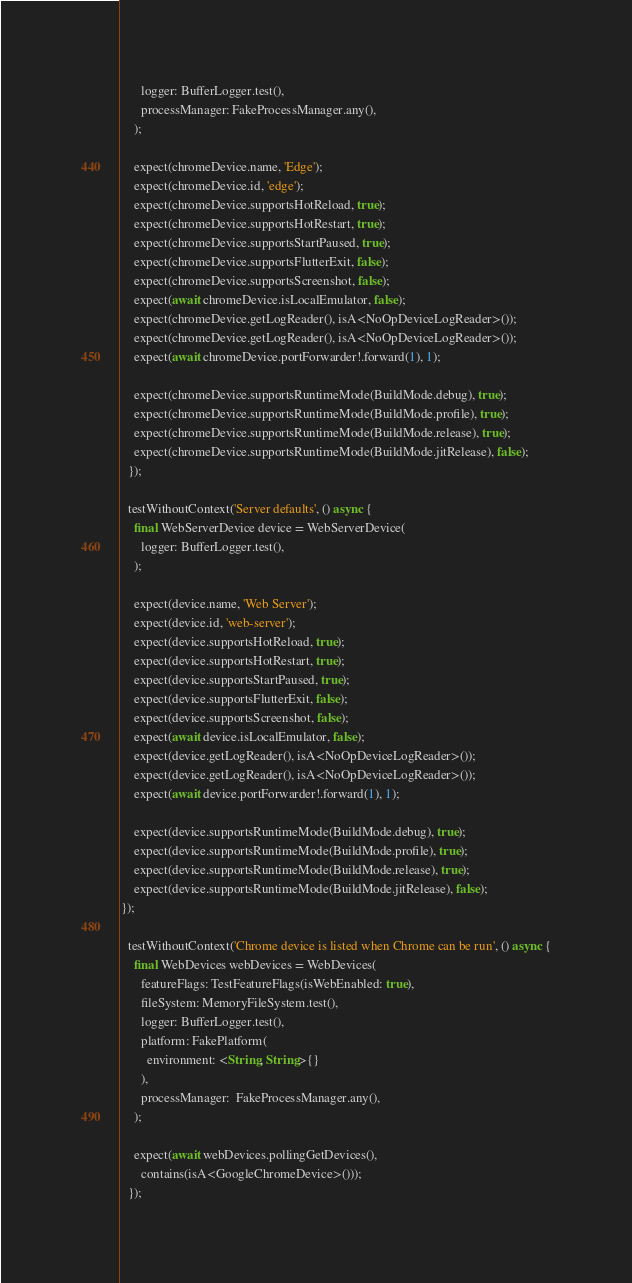Convert code to text. <code><loc_0><loc_0><loc_500><loc_500><_Dart_>      logger: BufferLogger.test(),
      processManager: FakeProcessManager.any(),
    );

    expect(chromeDevice.name, 'Edge');
    expect(chromeDevice.id, 'edge');
    expect(chromeDevice.supportsHotReload, true);
    expect(chromeDevice.supportsHotRestart, true);
    expect(chromeDevice.supportsStartPaused, true);
    expect(chromeDevice.supportsFlutterExit, false);
    expect(chromeDevice.supportsScreenshot, false);
    expect(await chromeDevice.isLocalEmulator, false);
    expect(chromeDevice.getLogReader(), isA<NoOpDeviceLogReader>());
    expect(chromeDevice.getLogReader(), isA<NoOpDeviceLogReader>());
    expect(await chromeDevice.portForwarder!.forward(1), 1);

    expect(chromeDevice.supportsRuntimeMode(BuildMode.debug), true);
    expect(chromeDevice.supportsRuntimeMode(BuildMode.profile), true);
    expect(chromeDevice.supportsRuntimeMode(BuildMode.release), true);
    expect(chromeDevice.supportsRuntimeMode(BuildMode.jitRelease), false);
  });

  testWithoutContext('Server defaults', () async {
    final WebServerDevice device = WebServerDevice(
      logger: BufferLogger.test(),
    );

    expect(device.name, 'Web Server');
    expect(device.id, 'web-server');
    expect(device.supportsHotReload, true);
    expect(device.supportsHotRestart, true);
    expect(device.supportsStartPaused, true);
    expect(device.supportsFlutterExit, false);
    expect(device.supportsScreenshot, false);
    expect(await device.isLocalEmulator, false);
    expect(device.getLogReader(), isA<NoOpDeviceLogReader>());
    expect(device.getLogReader(), isA<NoOpDeviceLogReader>());
    expect(await device.portForwarder!.forward(1), 1);

    expect(device.supportsRuntimeMode(BuildMode.debug), true);
    expect(device.supportsRuntimeMode(BuildMode.profile), true);
    expect(device.supportsRuntimeMode(BuildMode.release), true);
    expect(device.supportsRuntimeMode(BuildMode.jitRelease), false);
});

  testWithoutContext('Chrome device is listed when Chrome can be run', () async {
    final WebDevices webDevices = WebDevices(
      featureFlags: TestFeatureFlags(isWebEnabled: true),
      fileSystem: MemoryFileSystem.test(),
      logger: BufferLogger.test(),
      platform: FakePlatform(
        environment: <String, String>{}
      ),
      processManager:  FakeProcessManager.any(),
    );

    expect(await webDevices.pollingGetDevices(),
      contains(isA<GoogleChromeDevice>()));
  });
</code> 